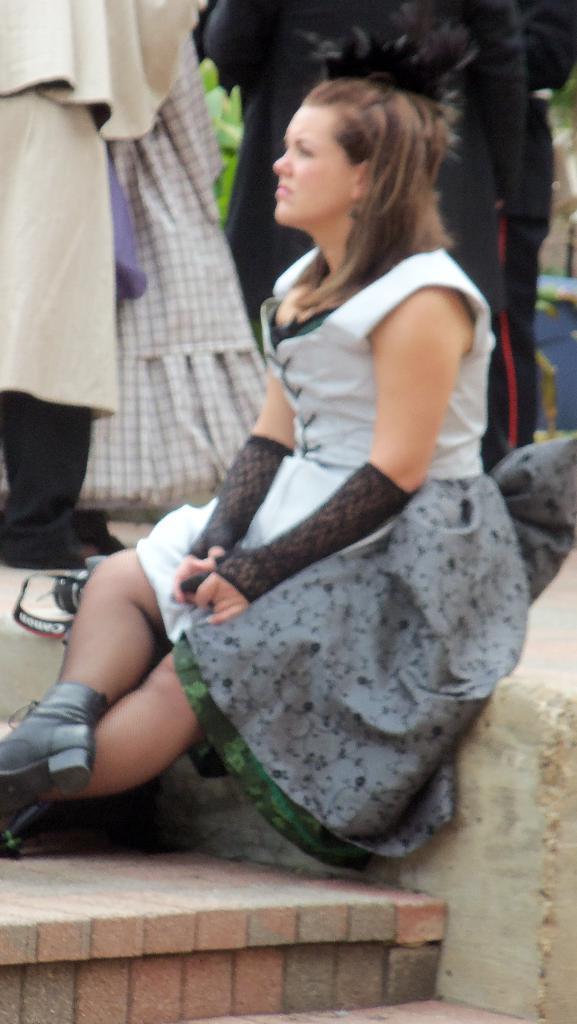Please provide a concise description of this image. In this image we can see few persons standing behind a lady. A lady is sitting on a wall. There is a camera beside a lady. 